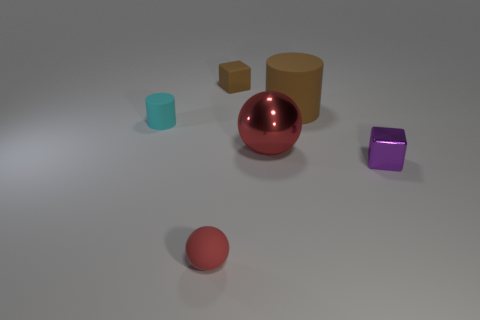Add 4 balls. How many objects exist? 10 Subtract all blocks. How many objects are left? 4 Subtract all brown cubes. Subtract all tiny brown cubes. How many objects are left? 4 Add 4 small brown cubes. How many small brown cubes are left? 5 Add 1 cyan rubber blocks. How many cyan rubber blocks exist? 1 Subtract 0 blue cylinders. How many objects are left? 6 